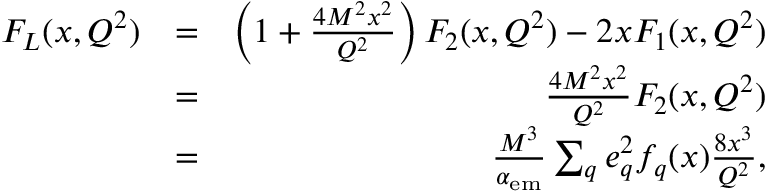<formula> <loc_0><loc_0><loc_500><loc_500>\begin{array} { r l r } { F _ { L } ( x , Q ^ { 2 } ) } & { = } & { \left ( 1 + \frac { 4 M ^ { 2 } x ^ { 2 } } { Q ^ { 2 } } \right ) F _ { 2 } ( x , Q ^ { 2 } ) - 2 x F _ { 1 } ( x , Q ^ { 2 } ) } \\ & { = } & { \frac { 4 M ^ { 2 } x ^ { 2 } } { Q ^ { 2 } } F _ { 2 } ( x , Q ^ { 2 } ) } \\ & { = } & { \frac { M ^ { 3 } } { \alpha _ { e m } } \sum _ { q } e _ { q } ^ { 2 } f _ { q } ( x ) \frac { 8 x ^ { 3 } } { Q ^ { 2 } } , } \end{array}</formula> 